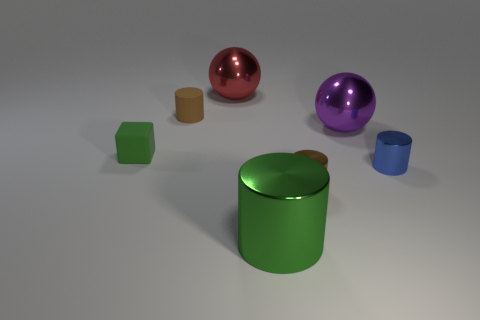Subtract all big cylinders. How many cylinders are left? 3 Subtract all green cylinders. How many cylinders are left? 3 Subtract all gray cylinders. Subtract all red balls. How many cylinders are left? 4 Add 3 red objects. How many objects exist? 10 Subtract all cubes. How many objects are left? 6 Subtract 0 cyan blocks. How many objects are left? 7 Subtract all blue cylinders. Subtract all big yellow things. How many objects are left? 6 Add 6 small objects. How many small objects are left? 10 Add 6 brown metal cylinders. How many brown metal cylinders exist? 7 